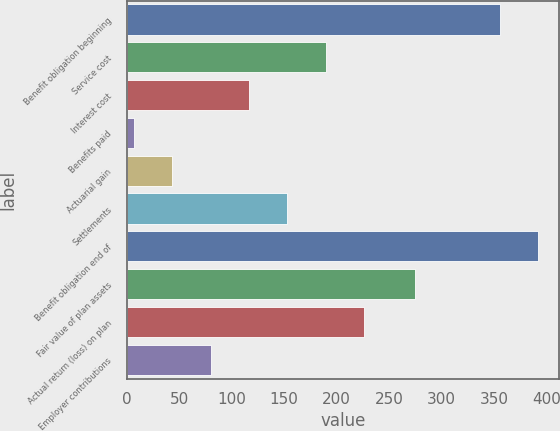Convert chart. <chart><loc_0><loc_0><loc_500><loc_500><bar_chart><fcel>Benefit obligation beginning<fcel>Service cost<fcel>Interest cost<fcel>Benefits paid<fcel>Actuarial gain<fcel>Settlements<fcel>Benefit obligation end of<fcel>Fair value of plan assets<fcel>Actual return (loss) on plan<fcel>Employer contributions<nl><fcel>356<fcel>189.5<fcel>116.5<fcel>7<fcel>43.5<fcel>153<fcel>392.5<fcel>275<fcel>226<fcel>80<nl></chart> 